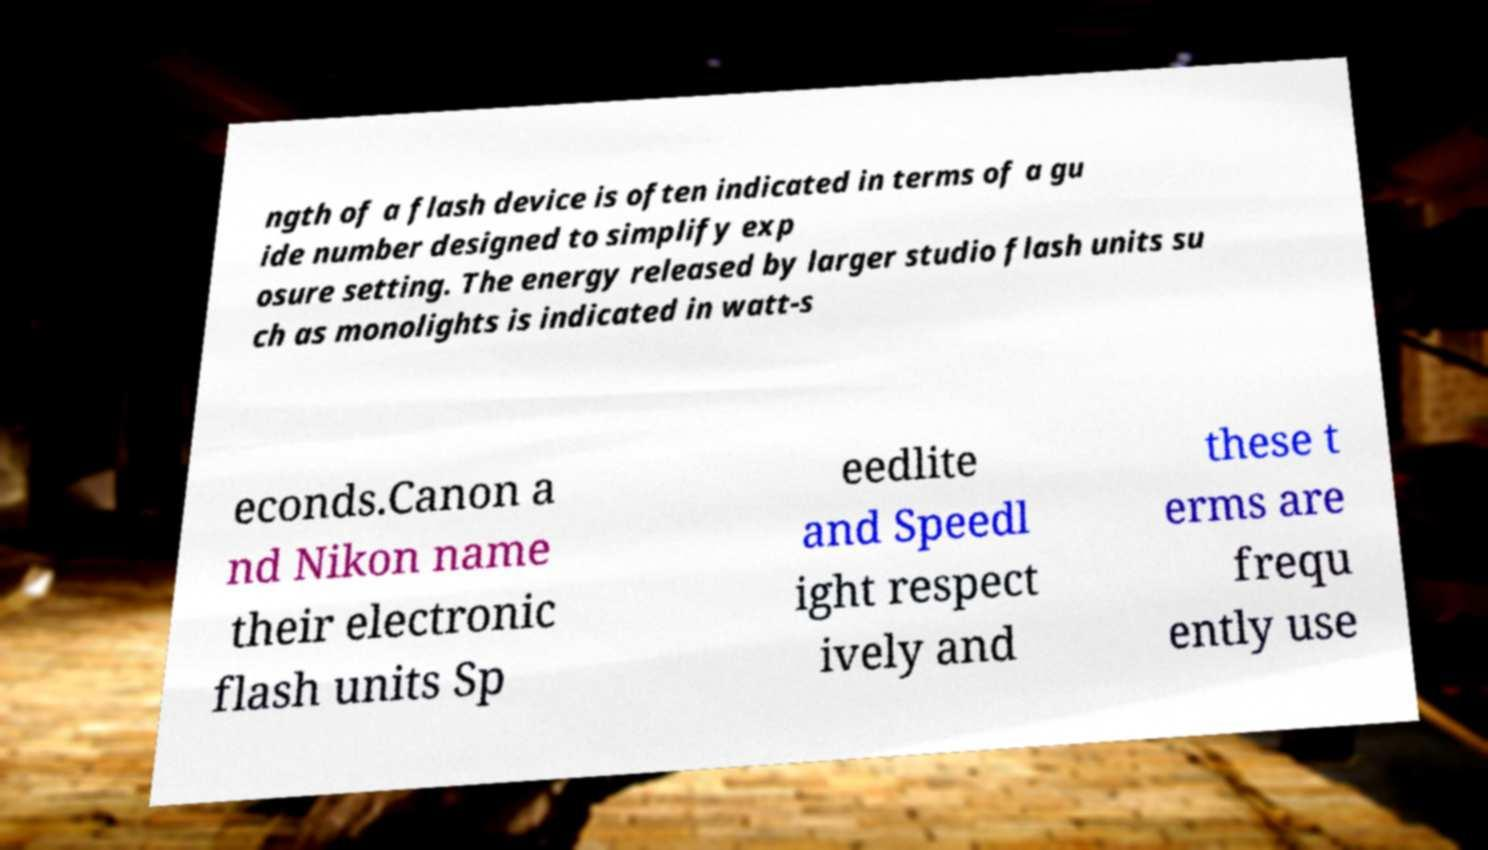I need the written content from this picture converted into text. Can you do that? ngth of a flash device is often indicated in terms of a gu ide number designed to simplify exp osure setting. The energy released by larger studio flash units su ch as monolights is indicated in watt-s econds.Canon a nd Nikon name their electronic flash units Sp eedlite and Speedl ight respect ively and these t erms are frequ ently use 